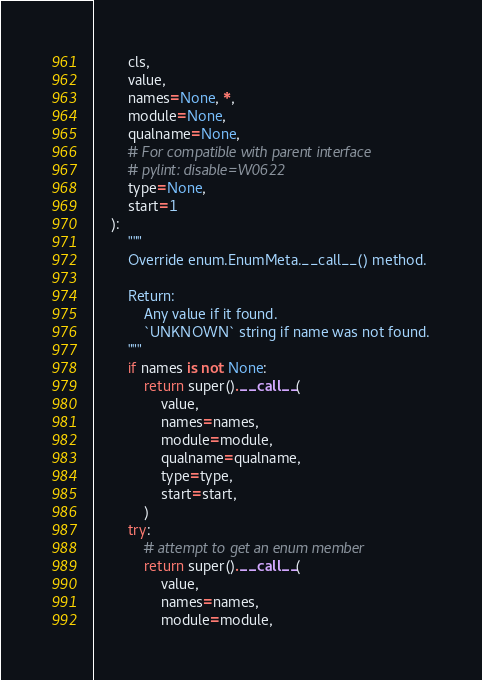<code> <loc_0><loc_0><loc_500><loc_500><_Python_>        cls,
        value,
        names=None, *,
        module=None,
        qualname=None,
        # For compatible with parent interface
        # pylint: disable=W0622
        type=None,
        start=1
    ):
        """
        Override enum.EnumMeta.__call__() method.

        Return:
            Any value if it found.
            `UNKNOWN` string if name was not found.
        """
        if names is not None:
            return super().__call__(
                value,
                names=names,
                module=module,
                qualname=qualname,
                type=type,
                start=start,
            )
        try:
            # attempt to get an enum member
            return super().__call__(
                value,
                names=names,
                module=module,</code> 